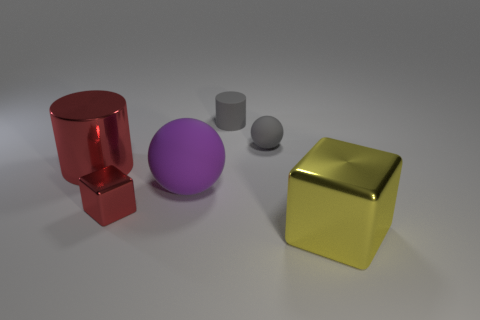Can you describe the colors and shapes of the objects present in the image? Certainly! The image showcases four objects with distinct colors and shapes. On the left, there's a large, red metal cylinder, and a small grey rubber cylinder is in front of a large, purple rubber sphere. Lastly, on the right, there's a cube with a shiny gold metallic surface. 